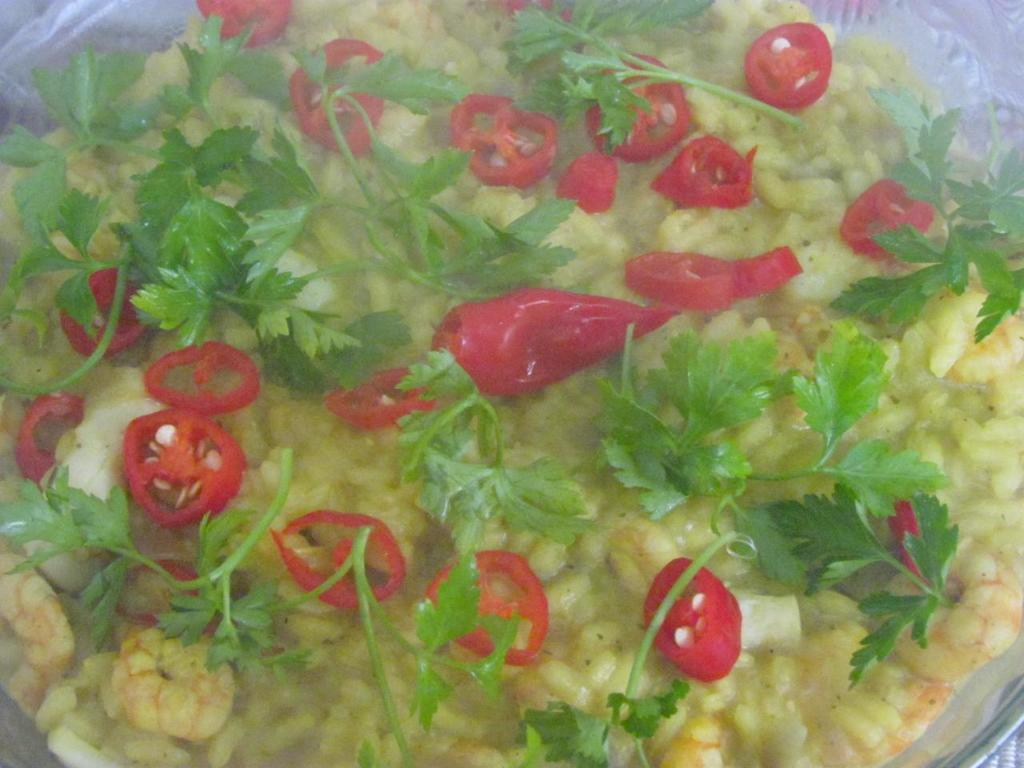What is present on the plate in the image? There are food items in the plate. Can you describe the food items on the plate? Unfortunately, the specific food items cannot be determined from the provided facts. What type of wool is being used to make the plate in the image? There is no wool present in the image, as the plate is not made of wool. 